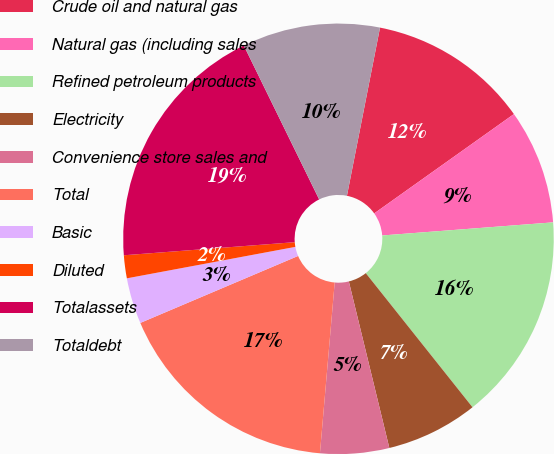<chart> <loc_0><loc_0><loc_500><loc_500><pie_chart><fcel>Crude oil and natural gas<fcel>Natural gas (including sales<fcel>Refined petroleum products<fcel>Electricity<fcel>Convenience store sales and<fcel>Total<fcel>Basic<fcel>Diluted<fcel>Totalassets<fcel>Totaldebt<nl><fcel>12.07%<fcel>8.62%<fcel>15.52%<fcel>6.9%<fcel>5.17%<fcel>17.24%<fcel>3.45%<fcel>1.72%<fcel>18.97%<fcel>10.34%<nl></chart> 